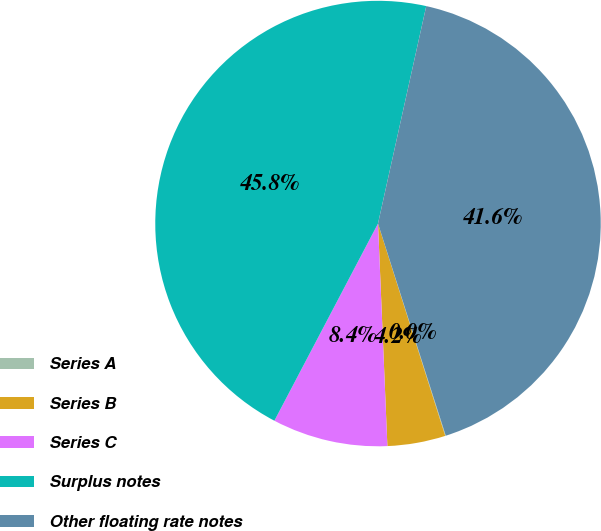Convert chart to OTSL. <chart><loc_0><loc_0><loc_500><loc_500><pie_chart><fcel>Series A<fcel>Series B<fcel>Series C<fcel>Surplus notes<fcel>Other floating rate notes<nl><fcel>0.04%<fcel>4.21%<fcel>8.37%<fcel>45.77%<fcel>41.6%<nl></chart> 